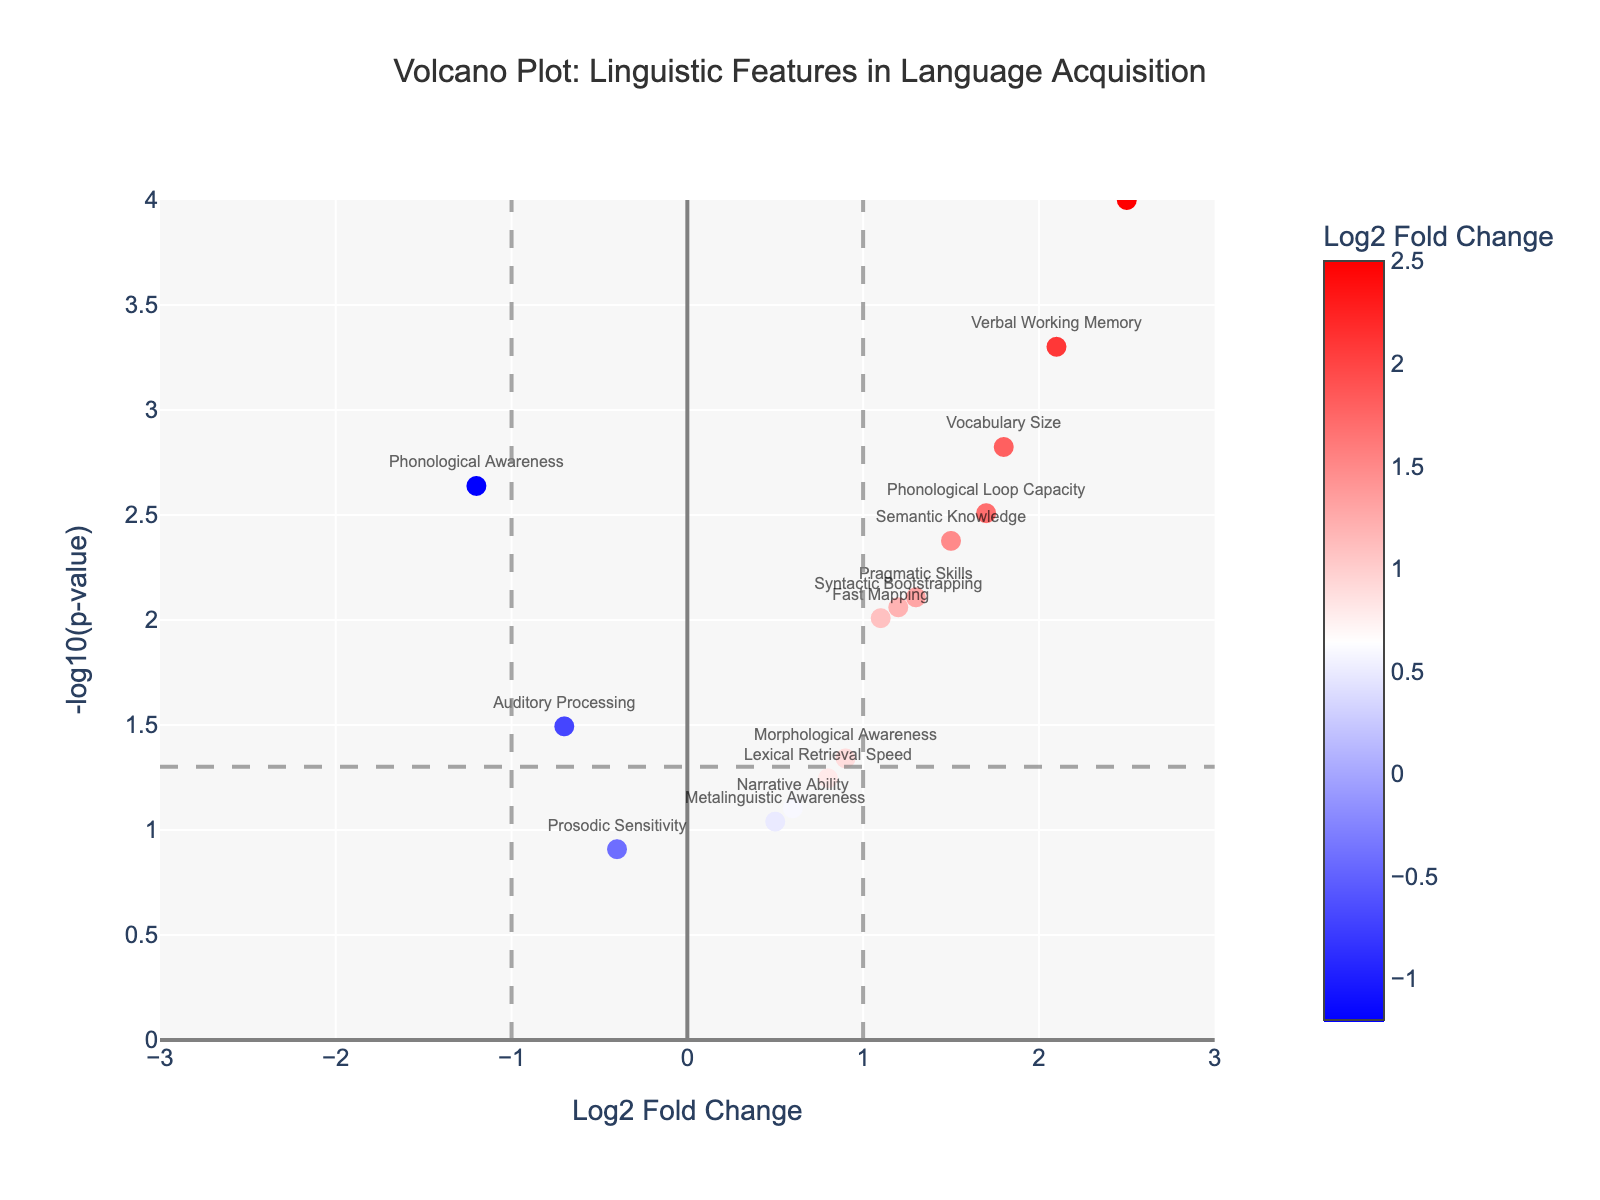what is the title of this plot? The title of this plot is written at the top of the figure. It reads "Volcano Plot: Linguistic Features in Language Acquisition".
Answer: Volcano Plot: Linguistic Features in Language Acquisition How many linguistic features have a Log2 Fold Change greater than 1? Identify the points in the plot where the Log2 Fold Change is greater than 1. These points fall on the right side of the x-axis at values greater than 1. Count these points: Syntax Complexity, Vocabulary Size, Verbal Working Memory, Semantic Knowledge, Phonological Loop Capacity, Fast Mapping, Syntactic Bootstrapping, and Pragmatic Skills.
Answer: Eight features What is the p-value threshold indicated by the horizontal dashed line? The horizontal dashed line represents the commonly used p-value threshold of 0.05. The y-coordinate of this line is the -log10 transformation of 0.05. Calculate -log10(0.05) = 1.3
Answer: 1.3 Which feature has the most negative Log2 Fold Change and is it statistically significant at p < 0.05? Look for the feature with the most negative Log2 Fold Change. It is Phonological Awareness with a Log2 Fold Change of -1.2. To check its statistical significance, review its p-value, which is 0.0023. Since 0.0023 < 0.05, it is statistically significant.
Answer: Phonological Awareness is significant Which feature has the highest -log10(p-value)? Examine the y-axis for the point that reaches the highest value. This is the Syntax Complexity feature.
Answer: Syntax Complexity Which features fall within one standard unit on the Log2 Fold Change axis but are not statistically significant? Standard units on the x-axis range from -1 to 1. These features are Morphological Awareness, Prosodic Sensitivity, Narrative Ability, Lexical Retrieval Speed, and Metalinguistic Awareness. Check their p-values: all have p-values > 0.05, indicating non-significance.
Answer: Prosodic Sensitivity, Narrative Ability, Lexical Retrieval Speed, Metalinguistic Awareness, Morphological Awareness Compare the significance of Verbal Working Memory and Phonological Loop Capacity. Which is more statistically significant? Find the y-values for these features on the plot (their -log10(p-values)). Verbal Working Memory has a higher y-value (indicating a lower p-value) compared to Phonological Loop Capacity.
Answer: Verbal Working Memory Is Semantic Knowledge statistically significant and what is its Log2 Fold Change? Check the position of Semantic Knowledge on the plot. Its -log10(p-value) is above 1.3, which means it is significant (p < 0.05). Its Log2 Fold Change is 1.5.
Answer: Yes, 1.5 Which feature has a Log2 Fold Change closest to zero but just above the significance threshold? Identify the feature closest to zero on the x-axis but with a height above the y-axis threshold line (1.3). This is Morphological Awareness. Its Log2 Fold Change is 0.9 and its p-value is 0.0456 (which makes it significant).
Answer: Morphological Awareness What is the range of the x-axis and what does it represent? The range of the x-axis is shown from -3 to 3, representing the Log2 Fold Change in linguistic features.
Answer: -3 to 3 